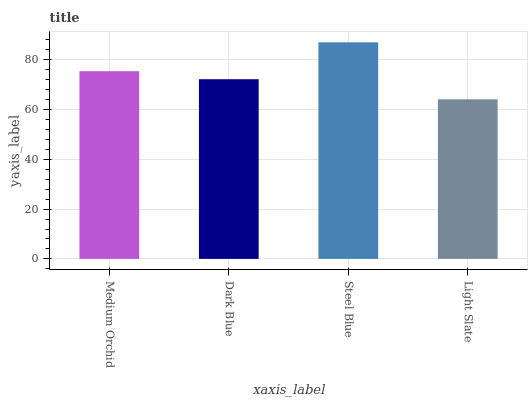Is Light Slate the minimum?
Answer yes or no. Yes. Is Steel Blue the maximum?
Answer yes or no. Yes. Is Dark Blue the minimum?
Answer yes or no. No. Is Dark Blue the maximum?
Answer yes or no. No. Is Medium Orchid greater than Dark Blue?
Answer yes or no. Yes. Is Dark Blue less than Medium Orchid?
Answer yes or no. Yes. Is Dark Blue greater than Medium Orchid?
Answer yes or no. No. Is Medium Orchid less than Dark Blue?
Answer yes or no. No. Is Medium Orchid the high median?
Answer yes or no. Yes. Is Dark Blue the low median?
Answer yes or no. Yes. Is Dark Blue the high median?
Answer yes or no. No. Is Light Slate the low median?
Answer yes or no. No. 